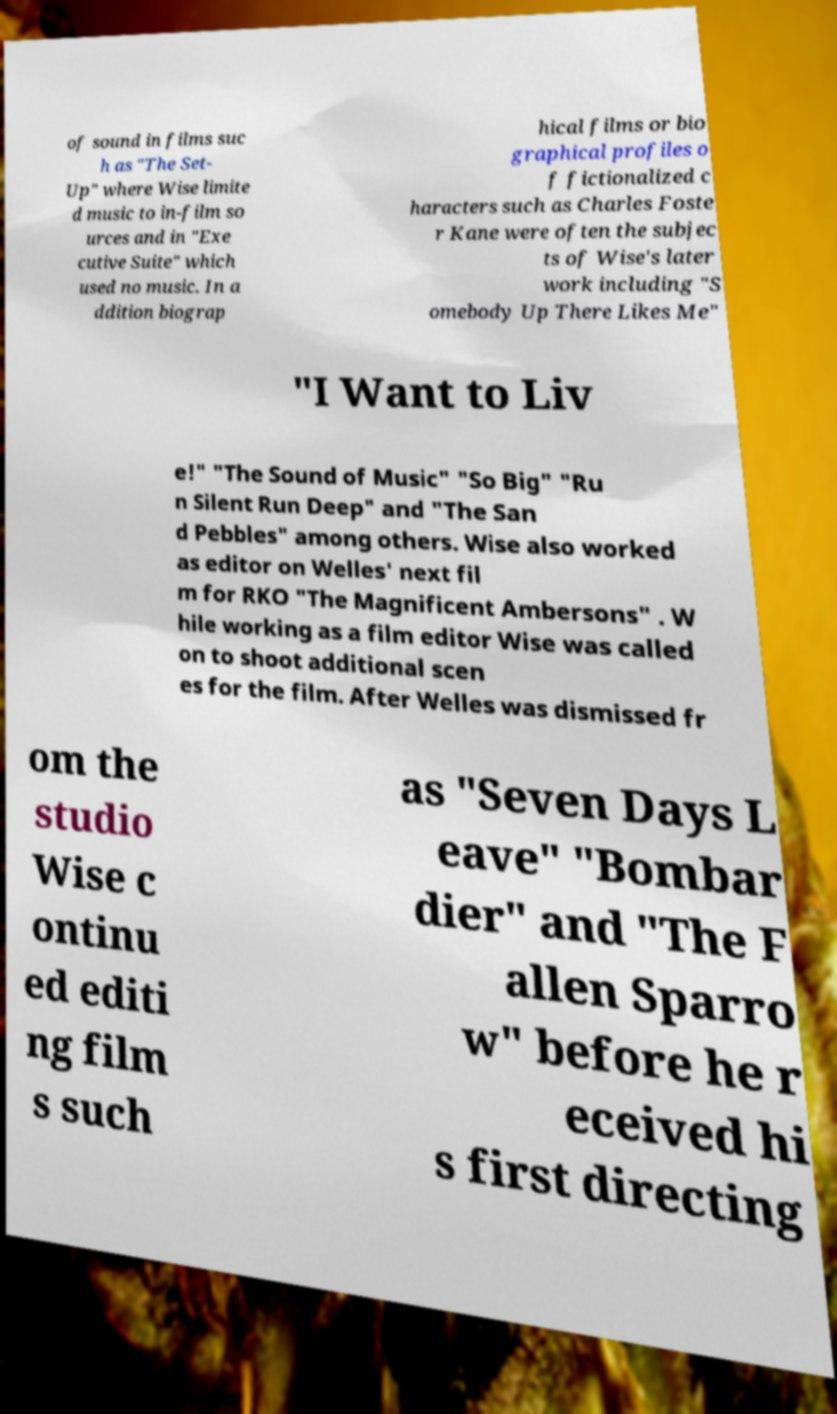I need the written content from this picture converted into text. Can you do that? of sound in films suc h as "The Set- Up" where Wise limite d music to in-film so urces and in "Exe cutive Suite" which used no music. In a ddition biograp hical films or bio graphical profiles o f fictionalized c haracters such as Charles Foste r Kane were often the subjec ts of Wise's later work including "S omebody Up There Likes Me" "I Want to Liv e!" "The Sound of Music" "So Big" "Ru n Silent Run Deep" and "The San d Pebbles" among others. Wise also worked as editor on Welles' next fil m for RKO "The Magnificent Ambersons" . W hile working as a film editor Wise was called on to shoot additional scen es for the film. After Welles was dismissed fr om the studio Wise c ontinu ed editi ng film s such as "Seven Days L eave" "Bombar dier" and "The F allen Sparro w" before he r eceived hi s first directing 